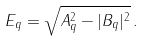Convert formula to latex. <formula><loc_0><loc_0><loc_500><loc_500>E _ { q } = \sqrt { A _ { q } ^ { 2 } - | B _ { q } | ^ { 2 } } \, .</formula> 